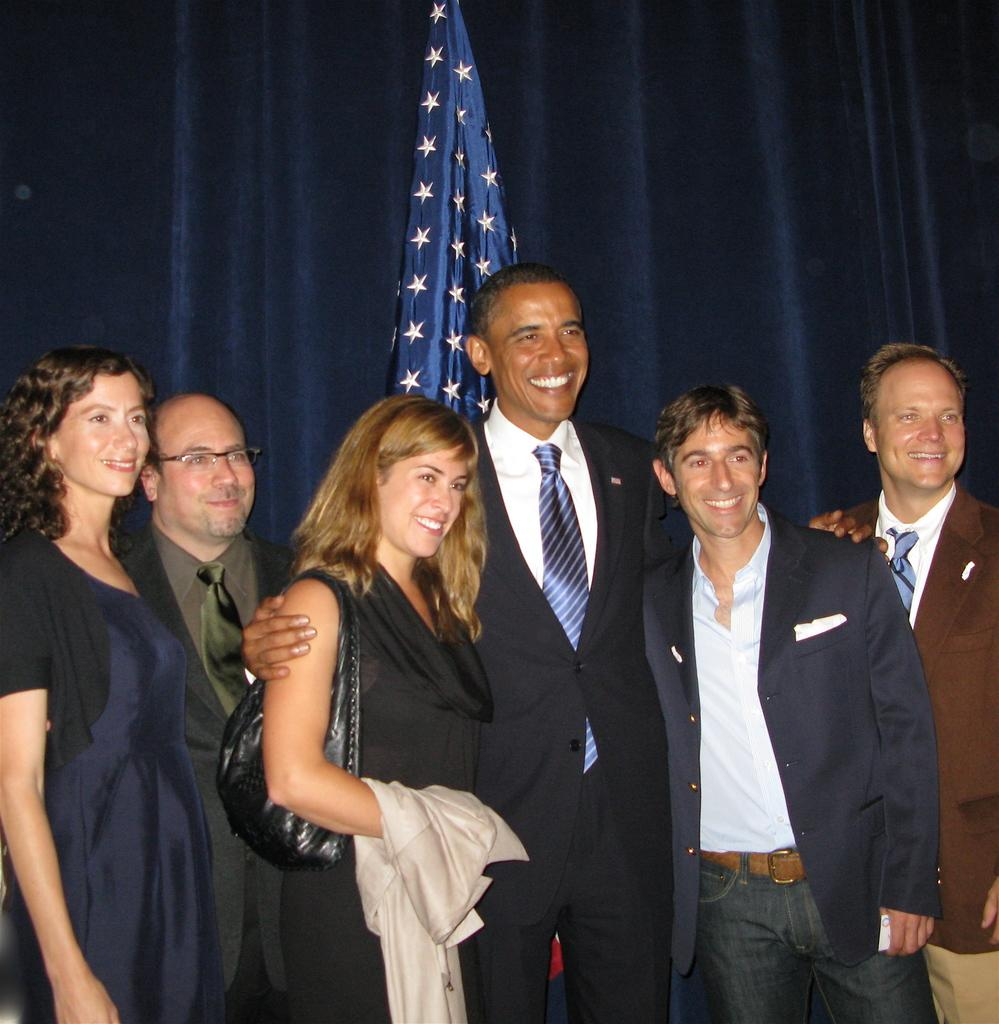How many people are in the image? There are persons standing in the image. What is the facial expression of the persons in the image? The persons are smiling. What object can be seen in the image that represents a country or organization? There is a flag in the image. What type of window treatment is present in the image? There is a curtain in the image. What type of lead can be seen being exchanged between the persons in the image? There is no lead or exchange of any kind depicted in the image. 